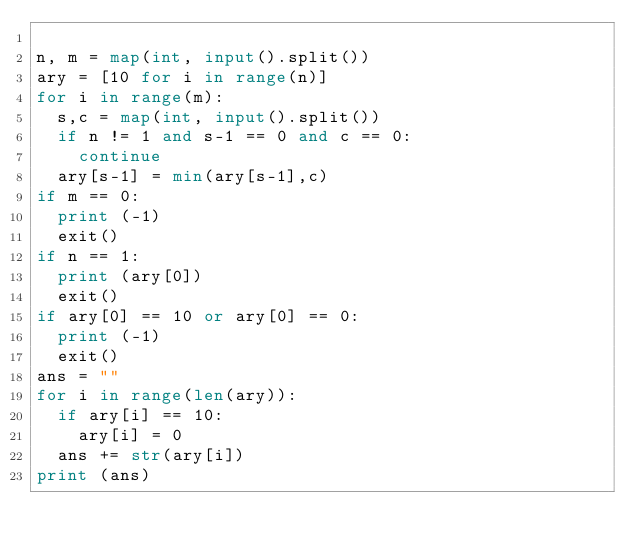Convert code to text. <code><loc_0><loc_0><loc_500><loc_500><_Python_>
n, m = map(int, input().split())
ary = [10 for i in range(n)]
for i in range(m):
	s,c = map(int, input().split())
	if n != 1 and s-1 == 0 and c == 0:
		continue
	ary[s-1] = min(ary[s-1],c)
if m == 0:
	print (-1)
	exit()
if n == 1:
	print (ary[0])
	exit()
if ary[0] == 10 or ary[0] == 0:
	print (-1)
	exit()
ans = ""
for i in range(len(ary)):
	if ary[i] == 10:
		ary[i] = 0
	ans += str(ary[i])
print (ans)</code> 